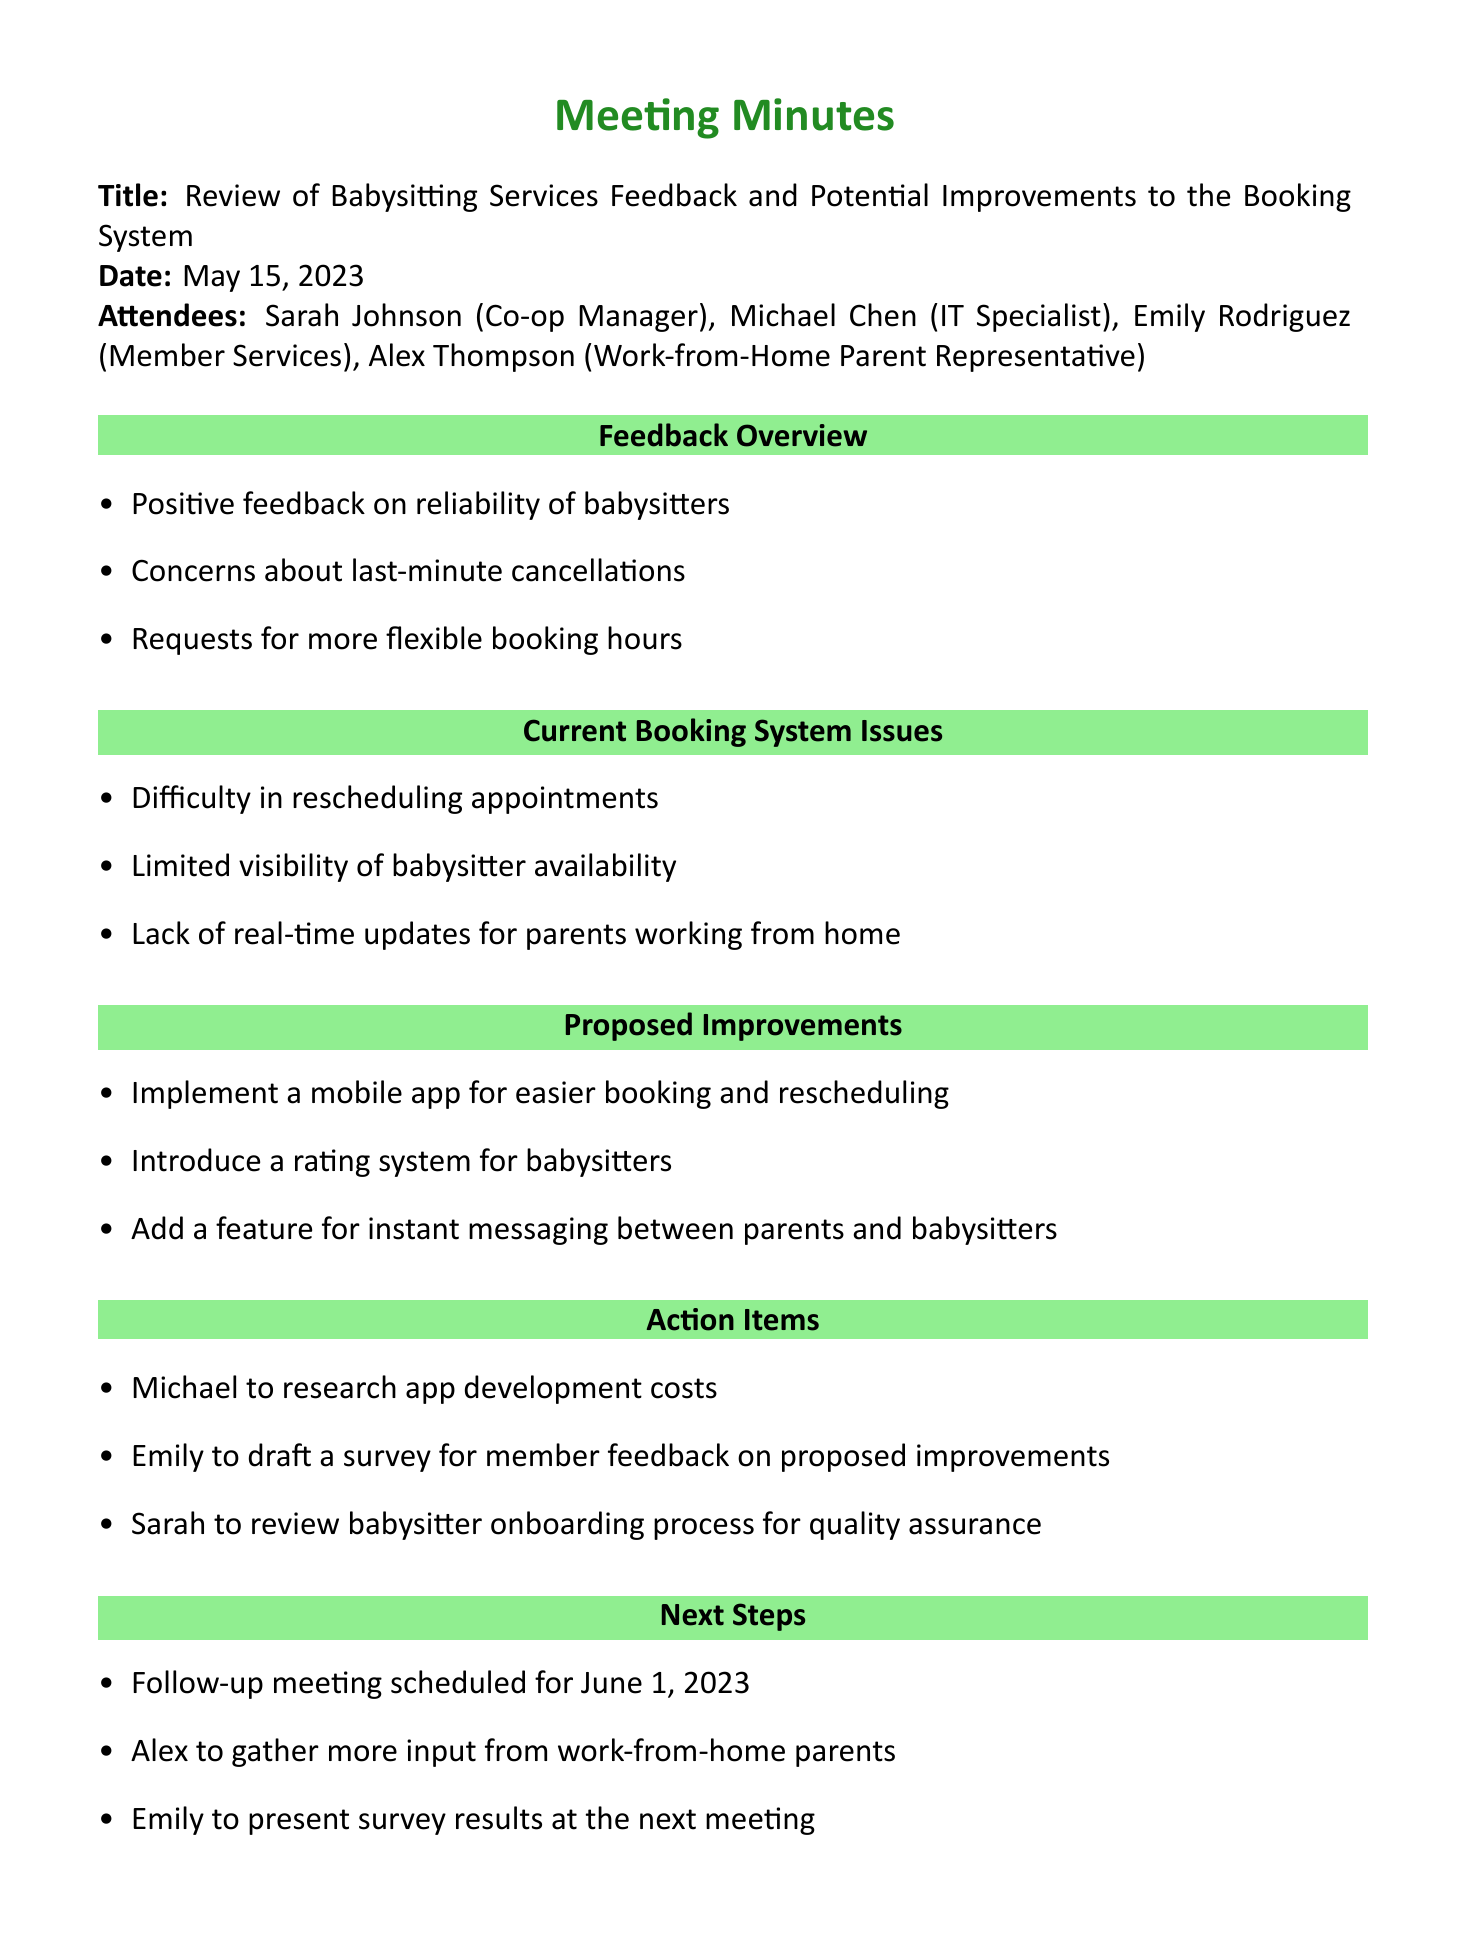What is the date of the meeting? The date of the meeting is mentioned clearly in the document as May 15, 2023.
Answer: May 15, 2023 Who is the Co-op Manager? The document lists Sarah Johnson as the Co-op Manager among the attendees.
Answer: Sarah Johnson What is one of the positive feedback points on babysitting services? The document states that there was positive feedback on the reliability of babysitters.
Answer: Reliability of babysitters What system issue relates to parenting while working from home? The document mentions the lack of real-time updates for parents working from home as a system issue.
Answer: Lack of real-time updates What improvement involves communication between parents and babysitters? The document proposes adding a feature for instant messaging between parents and babysitters.
Answer: Instant messaging How many attendees were present at the meeting? The document lists four attendees, highlighting their roles in the co-op.
Answer: Four What is one action item assigned to Michael? The document indicates that Michael is tasked with researching app development costs.
Answer: Research app development costs When is the follow-up meeting scheduled? The document states that the follow-up meeting is scheduled for June 1, 2023.
Answer: June 1, 2023 Who is responsible for drafting the survey? According to the document, Emily is to draft a survey for member feedback on proposed improvements.
Answer: Emily 